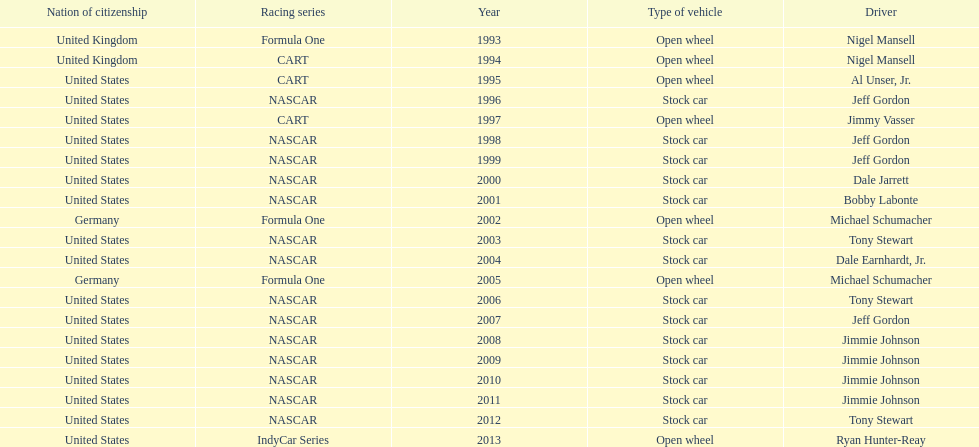Which racing series has the highest total of winners? NASCAR. 